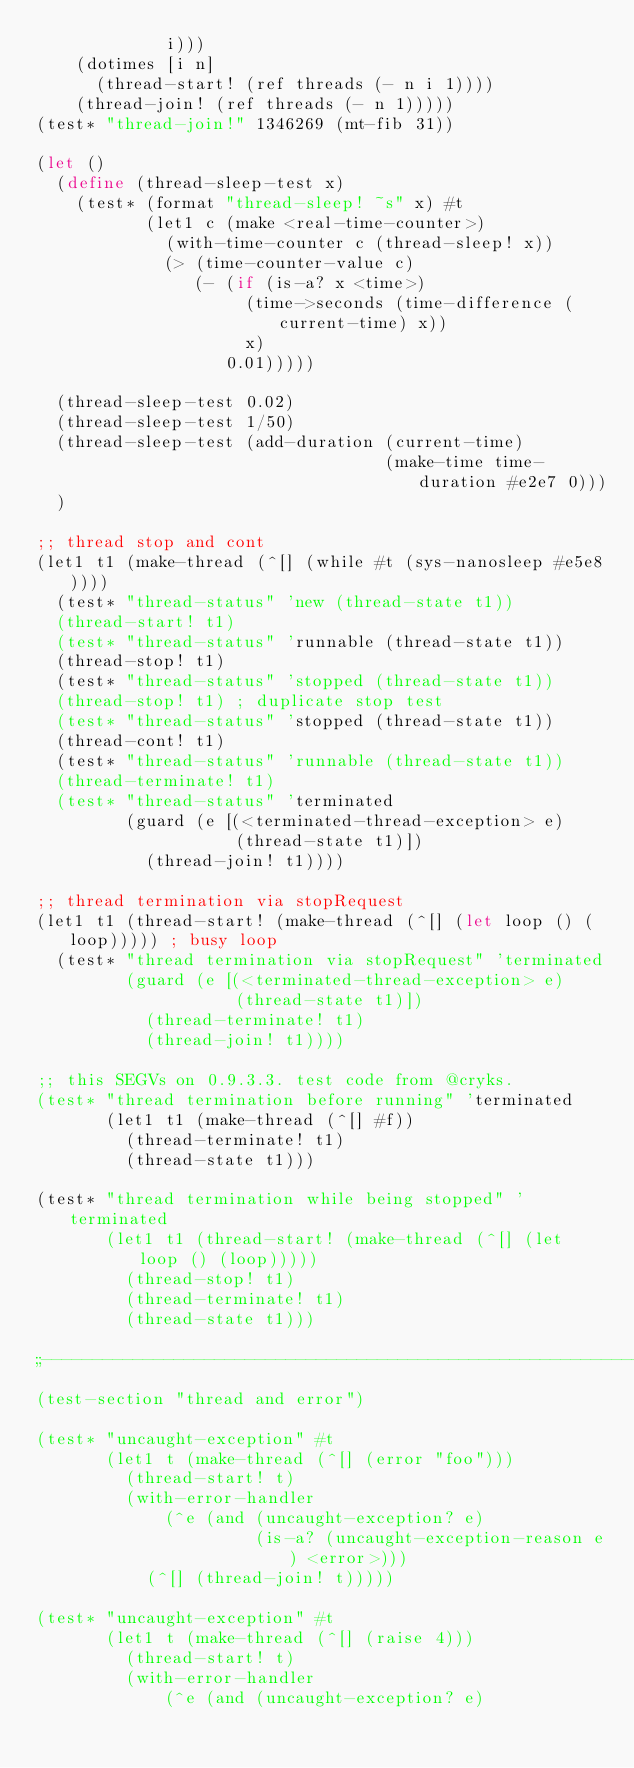<code> <loc_0><loc_0><loc_500><loc_500><_Scheme_>             i)))
    (dotimes [i n]
      (thread-start! (ref threads (- n i 1))))
    (thread-join! (ref threads (- n 1)))))
(test* "thread-join!" 1346269 (mt-fib 31))

(let ()
  (define (thread-sleep-test x)
    (test* (format "thread-sleep! ~s" x) #t
           (let1 c (make <real-time-counter>)
             (with-time-counter c (thread-sleep! x))
             (> (time-counter-value c)
                (- (if (is-a? x <time>)
                     (time->seconds (time-difference (current-time) x))
                     x)
                   0.01)))))

  (thread-sleep-test 0.02)
  (thread-sleep-test 1/50)
  (thread-sleep-test (add-duration (current-time)
                                   (make-time time-duration #e2e7 0)))
  )

;; thread stop and cont
(let1 t1 (make-thread (^[] (while #t (sys-nanosleep #e5e8))))
  (test* "thread-status" 'new (thread-state t1))
  (thread-start! t1)
  (test* "thread-status" 'runnable (thread-state t1))
  (thread-stop! t1)
  (test* "thread-status" 'stopped (thread-state t1))
  (thread-stop! t1) ; duplicate stop test
  (test* "thread-status" 'stopped (thread-state t1))
  (thread-cont! t1)
  (test* "thread-status" 'runnable (thread-state t1))
  (thread-terminate! t1)
  (test* "thread-status" 'terminated
         (guard (e [(<terminated-thread-exception> e)
                    (thread-state t1)])
           (thread-join! t1))))

;; thread termination via stopRequest
(let1 t1 (thread-start! (make-thread (^[] (let loop () (loop))))) ; busy loop
  (test* "thread termination via stopRequest" 'terminated
         (guard (e [(<terminated-thread-exception> e)
                    (thread-state t1)])
           (thread-terminate! t1)
           (thread-join! t1))))

;; this SEGVs on 0.9.3.3. test code from @cryks.
(test* "thread termination before running" 'terminated
       (let1 t1 (make-thread (^[] #f))
         (thread-terminate! t1)
         (thread-state t1)))

(test* "thread termination while being stopped" 'terminated
       (let1 t1 (thread-start! (make-thread (^[] (let loop () (loop)))))
         (thread-stop! t1)
         (thread-terminate! t1)
         (thread-state t1)))

;;---------------------------------------------------------------------
(test-section "thread and error")

(test* "uncaught-exception" #t
       (let1 t (make-thread (^[] (error "foo")))
         (thread-start! t)
         (with-error-handler
             (^e (and (uncaught-exception? e)
                      (is-a? (uncaught-exception-reason e) <error>)))
           (^[] (thread-join! t)))))

(test* "uncaught-exception" #t
       (let1 t (make-thread (^[] (raise 4)))
         (thread-start! t)
         (with-error-handler
             (^e (and (uncaught-exception? e)</code> 